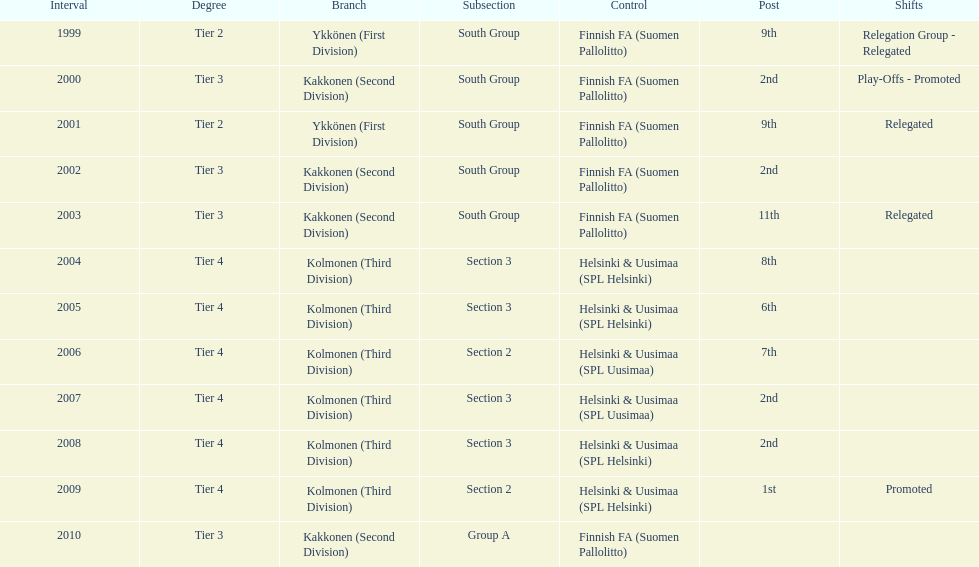Which was the only kolmonen whose movements were promoted? 2009. 